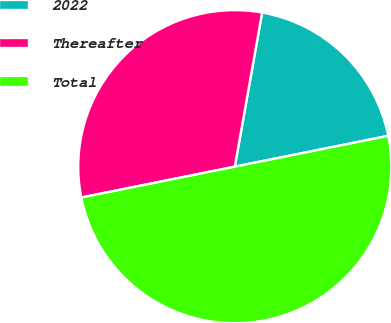Convert chart. <chart><loc_0><loc_0><loc_500><loc_500><pie_chart><fcel>2022<fcel>Thereafter<fcel>Total<nl><fcel>19.05%<fcel>30.95%<fcel>50.0%<nl></chart> 